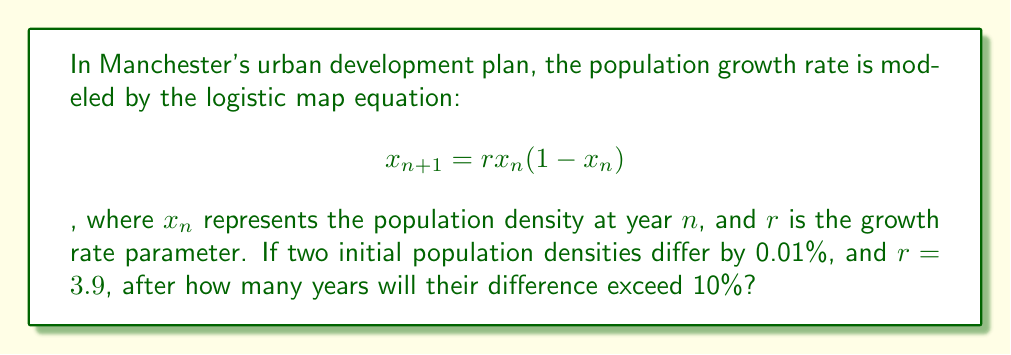Provide a solution to this math problem. To solve this problem, we need to iterate the logistic map equation and compare the trajectories of two slightly different initial conditions:

1. Let's start with two initial population densities: $x_0 = 0.5$ and $y_0 = 0.5005$ (0.01% difference).

2. We'll use the logistic map equation to calculate subsequent values:
   $$x_{n+1} = 3.9x_n(1-x_n)$$
   $$y_{n+1} = 3.9y_n(1-y_n)$$

3. We'll iterate until the difference between $x_n$ and $y_n$ exceeds 10% (0.1).

4. Here are the first few iterations:

   n = 0: x₀ = 0.5000, y₀ = 0.5005, diff = 0.0005
   n = 1: x₁ = 0.9750, y₁ = 0.9749, diff = 0.0001
   n = 2: x₂ = 0.0949, y₂ = 0.0952, diff = 0.0003
   n = 3: x₃ = 0.3345, y₃ = 0.3355, diff = 0.0010
   n = 4: x₄ = 0.8680, y₄ = 0.8690, diff = 0.0010
   n = 5: x₅ = 0.4461, y₅ = 0.4437, diff = 0.0024
   ...
   n = 13: x₁₃ = 0.9539, y₁₃ = 0.8523, diff = 0.1016

5. After 13 iterations, the difference exceeds 10%.

This demonstrates the sensitivity to initial conditions in the logistic map, a key concept in chaos theory. Even a tiny initial difference can lead to significantly different outcomes over time, which is relevant to urban development planning in Manchester.
Answer: 13 years 